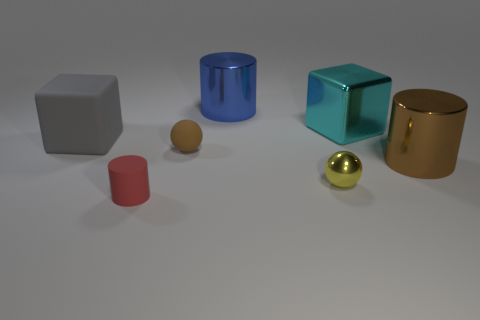Is there any other thing that has the same size as the yellow thing?
Your response must be concise. Yes. Is the material of the block to the left of the tiny matte cylinder the same as the big brown object?
Your answer should be compact. No. Are there fewer yellow objects behind the big rubber cube than red rubber balls?
Ensure brevity in your answer.  No. How many rubber objects are small brown things or large purple blocks?
Your response must be concise. 1. Is there any other thing that has the same color as the tiny matte cylinder?
Your answer should be compact. No. There is a small matte thing left of the brown rubber object; is it the same shape as the brown thing on the right side of the brown sphere?
Give a very brief answer. Yes. What number of objects are either cubes or small balls in front of the brown cylinder?
Keep it short and to the point. 3. How many other objects are the same size as the red cylinder?
Your response must be concise. 2. Do the sphere on the left side of the big blue cylinder and the large block left of the small red matte cylinder have the same material?
Provide a succinct answer. Yes. How many small yellow balls are in front of the yellow thing?
Offer a very short reply. 0. 